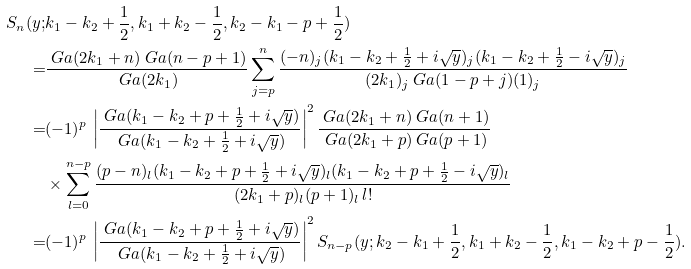<formula> <loc_0><loc_0><loc_500><loc_500>S _ { n } ( y ; & k _ { 1 } - k _ { 2 } + \frac { 1 } { 2 } , k _ { 1 } + k _ { 2 } - \frac { 1 } { 2 } , k _ { 2 } - k _ { 1 } - p + \frac { 1 } { 2 } ) \\ = & \frac { \ G a ( 2 k _ { 1 } + n ) \ G a ( n - p + 1 ) } { \ G a ( 2 k _ { 1 } ) } \sum _ { j = p } ^ { n } \frac { ( - n ) _ { j } ( k _ { 1 } - k _ { 2 } + \frac { 1 } { 2 } + i \sqrt { y } ) _ { j } ( k _ { 1 } - k _ { 2 } + \frac { 1 } { 2 } - i \sqrt { y } ) _ { j } } { ( 2 k _ { 1 } ) _ { j } \ G a ( 1 - p + j ) ( 1 ) _ { j } } \\ = & ( - 1 ) ^ { p } \, \left | \frac { \ G a ( k _ { 1 } - k _ { 2 } + p + \frac { 1 } { 2 } + i \sqrt { y } ) } { \ G a ( k _ { 1 } - k _ { 2 } + \frac { 1 } { 2 } + i \sqrt { y } ) } \right | ^ { 2 } \frac { \ G a ( 2 k _ { 1 } + n ) \ G a ( n + 1 ) } { \ G a ( 2 k _ { 1 } + p ) \ G a ( p + 1 ) } \\ & \times \sum _ { l = 0 } ^ { n - p } \frac { ( p - n ) _ { l } ( k _ { 1 } - k _ { 2 } + p + \frac { 1 } { 2 } + i \sqrt { y } ) _ { l } ( k _ { 1 } - k _ { 2 } + p + \frac { 1 } { 2 } - i \sqrt { y } ) _ { l } } { ( 2 k _ { 1 } + p ) _ { l } ( p + 1 ) _ { l } \, l ! } \\ = & ( - 1 ) ^ { p } \, \left | \frac { \ G a ( k _ { 1 } - k _ { 2 } + p + \frac { 1 } { 2 } + i \sqrt { y } ) } { \ G a ( k _ { 1 } - k _ { 2 } + \frac { 1 } { 2 } + i \sqrt { y } ) } \right | ^ { 2 } S _ { n - p } ( y ; k _ { 2 } - k _ { 1 } + \frac { 1 } { 2 } , k _ { 1 } + k _ { 2 } - \frac { 1 } { 2 } , k _ { 1 } - k _ { 2 } + p - \frac { 1 } { 2 } ) .</formula> 